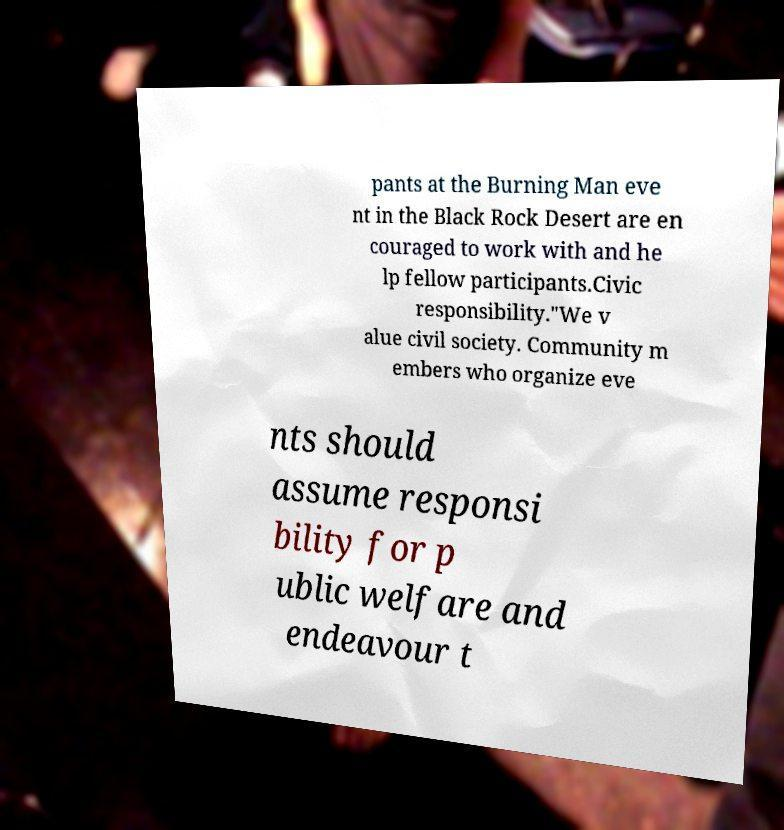Can you read and provide the text displayed in the image?This photo seems to have some interesting text. Can you extract and type it out for me? pants at the Burning Man eve nt in the Black Rock Desert are en couraged to work with and he lp fellow participants.Civic responsibility."We v alue civil society. Community m embers who organize eve nts should assume responsi bility for p ublic welfare and endeavour t 